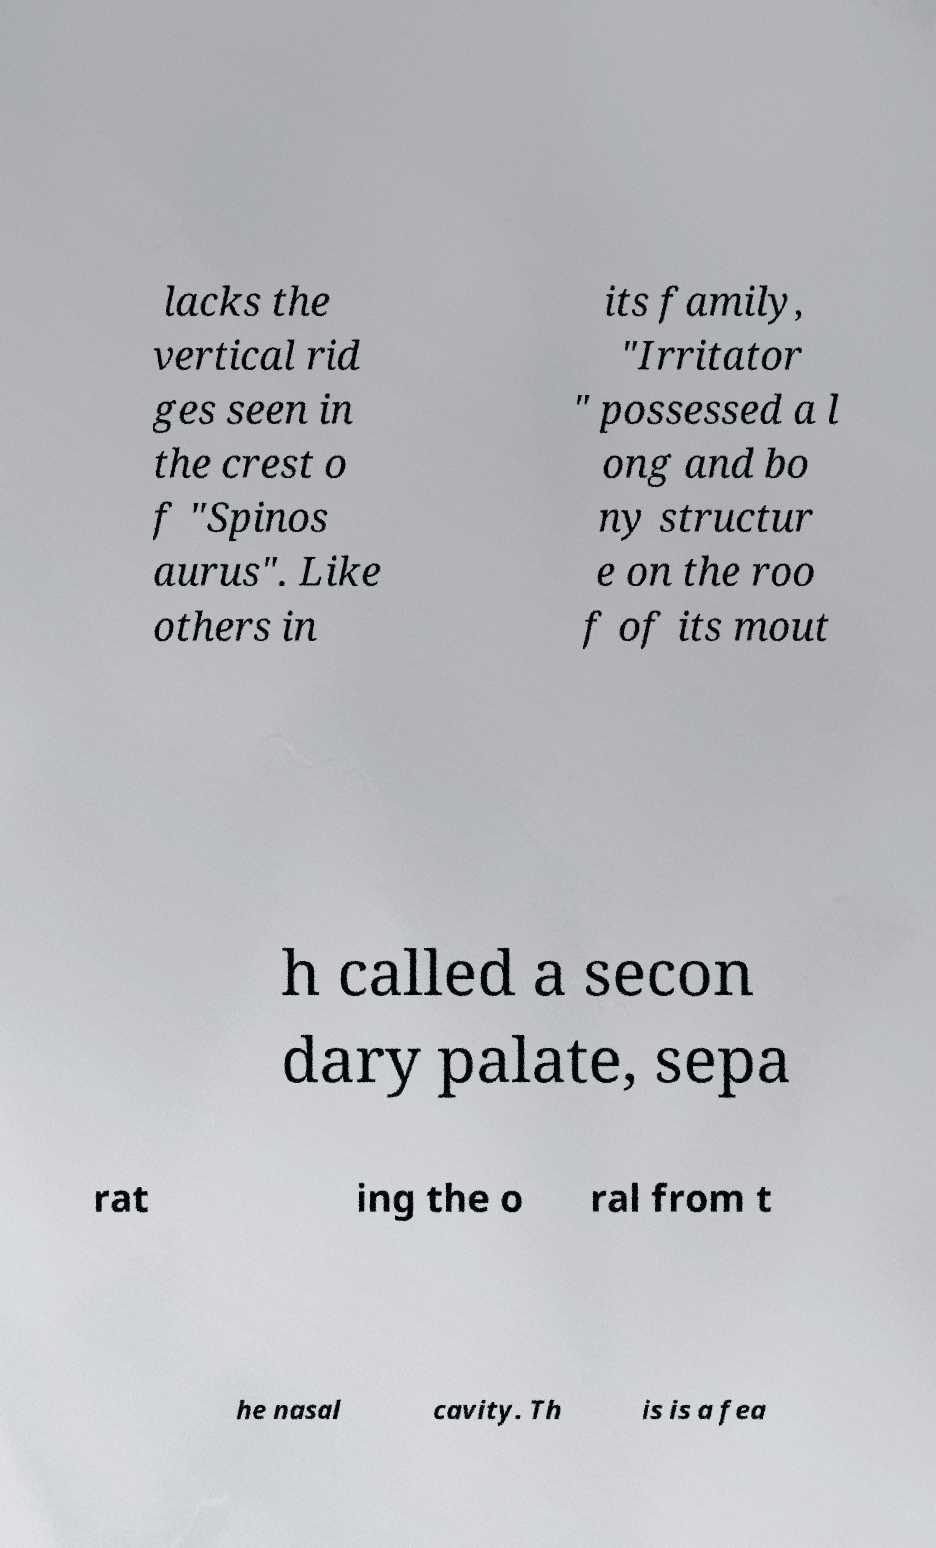Could you extract and type out the text from this image? lacks the vertical rid ges seen in the crest o f "Spinos aurus". Like others in its family, "Irritator " possessed a l ong and bo ny structur e on the roo f of its mout h called a secon dary palate, sepa rat ing the o ral from t he nasal cavity. Th is is a fea 